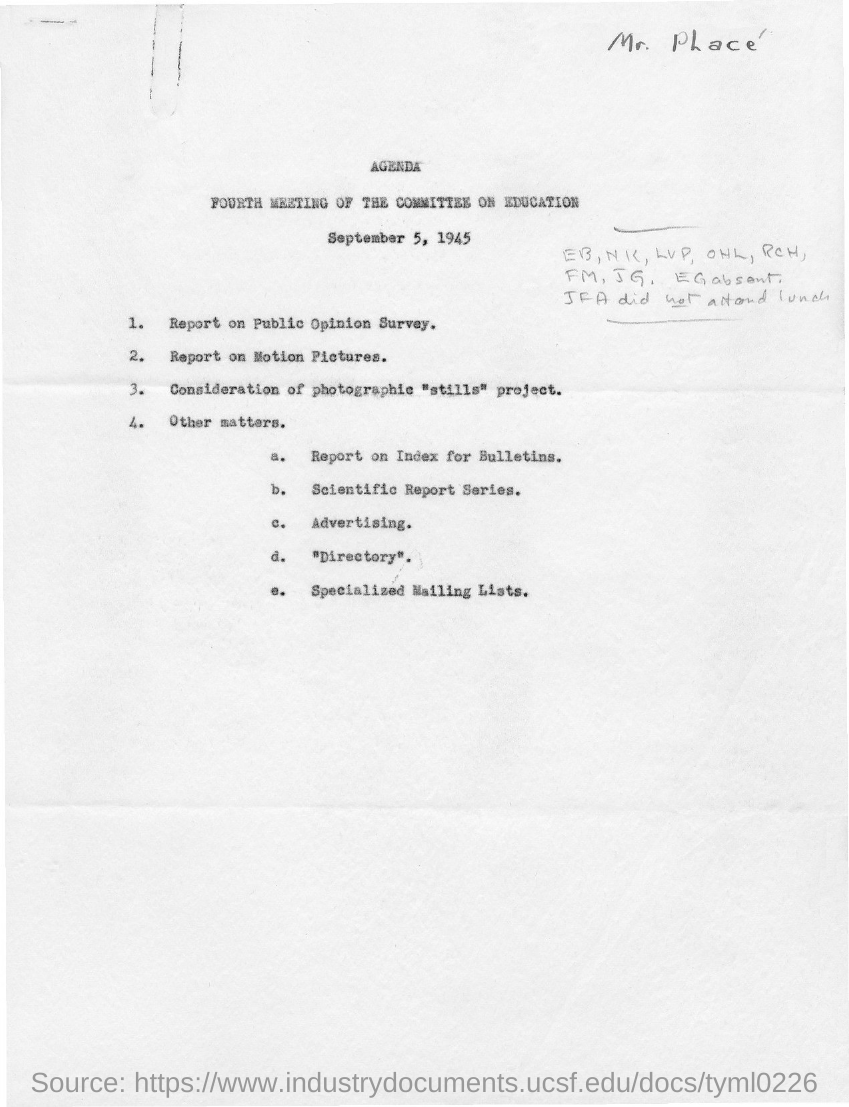Identify some key points in this picture. The fourth meeting of the committee on education was held on September 5, 1945. 